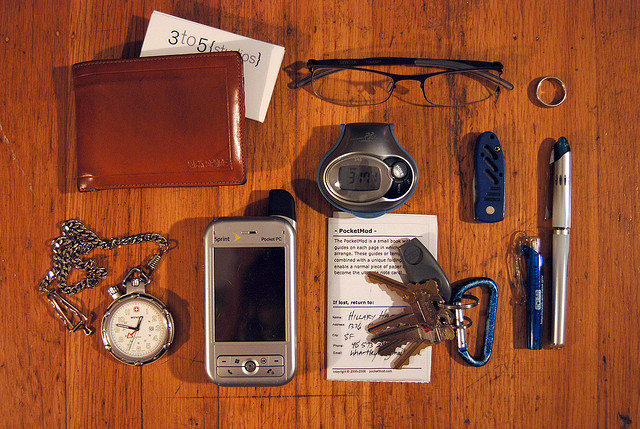Identify and read out the text in this image. PockolHod 3 HILLARY 5 to 